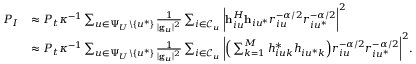Convert formula to latex. <formula><loc_0><loc_0><loc_500><loc_500>\begin{array} { r l } { P _ { I } } & { \approx P _ { t } \kappa ^ { - 1 } \sum _ { u \in \Psi _ { U } \ \{ u ^ { * } \} } \frac { 1 } { | g _ { u } | ^ { 2 } } \sum _ { i \in \mathcal { C } _ { u } } \left | h _ { i u } ^ { H } h _ { i u ^ { * } } r _ { i u } ^ { - \alpha / 2 } r _ { i u ^ { * } } ^ { - \alpha / 2 } \right | ^ { 2 } } \\ & { \approx P _ { t } \kappa ^ { - 1 } \sum _ { u \in \Psi _ { U } \ \{ u ^ { * } \} } \frac { 1 } { | g _ { u } | ^ { 2 } } \sum _ { i \in \mathcal { C } _ { u } } \left | \left ( \sum _ { k = 1 } ^ { M } h _ { i u k } ^ { * } h _ { i u ^ { * } k } \right ) r _ { i u } ^ { - \alpha / 2 } r _ { i u ^ { * } } ^ { - \alpha / 2 } \right | ^ { 2 } . } \end{array}</formula> 